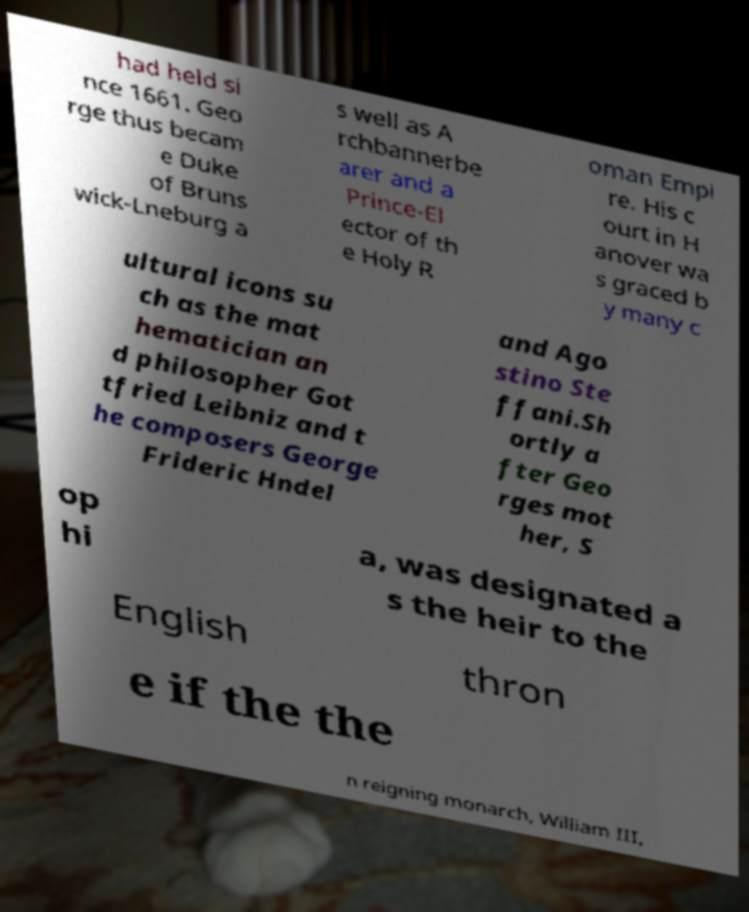Could you extract and type out the text from this image? had held si nce 1661. Geo rge thus becam e Duke of Bruns wick-Lneburg a s well as A rchbannerbe arer and a Prince-El ector of th e Holy R oman Empi re. His c ourt in H anover wa s graced b y many c ultural icons su ch as the mat hematician an d philosopher Got tfried Leibniz and t he composers George Frideric Hndel and Ago stino Ste ffani.Sh ortly a fter Geo rges mot her, S op hi a, was designated a s the heir to the English thron e if the the n reigning monarch, William III, 